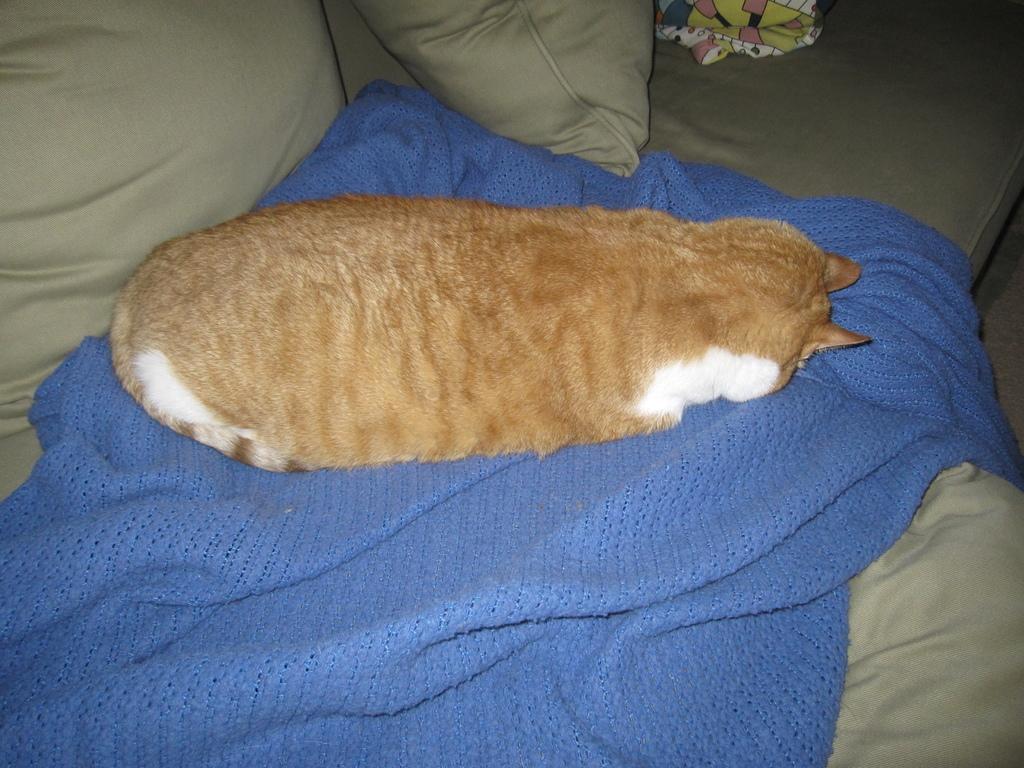Could you give a brief overview of what you see in this image? In this image we can see a cat is sitting on a cloth on the couch and we can see pillows and another cloth on the couch. 